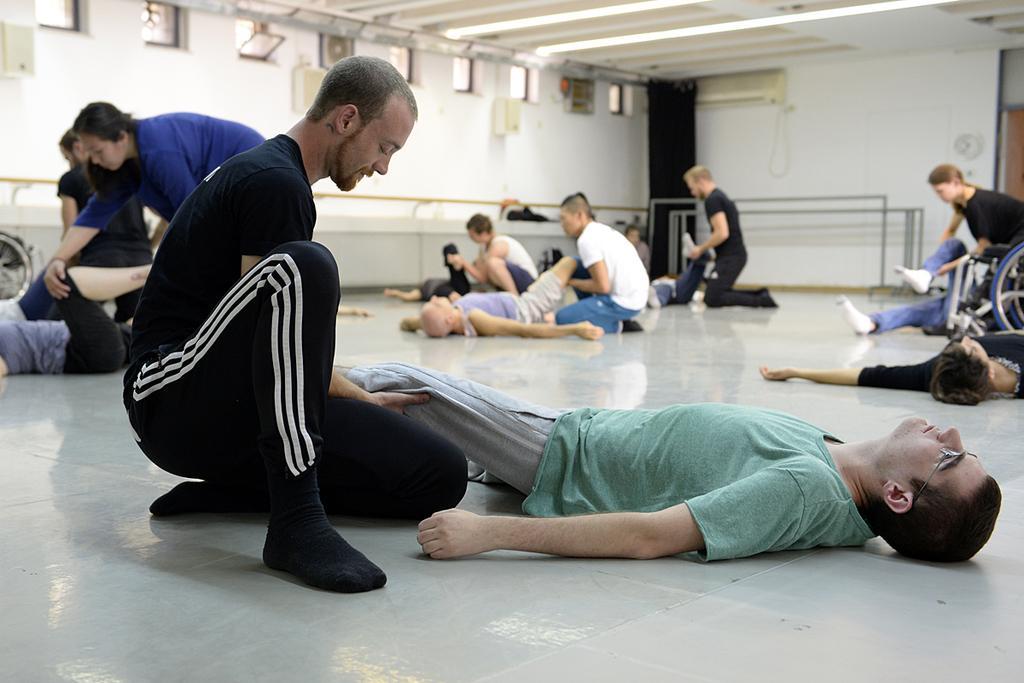Please provide a concise description of this image. There are many people lying on the floor. And some people are doing physiotherapy for this people. In the back there's a wall with ventilation. 